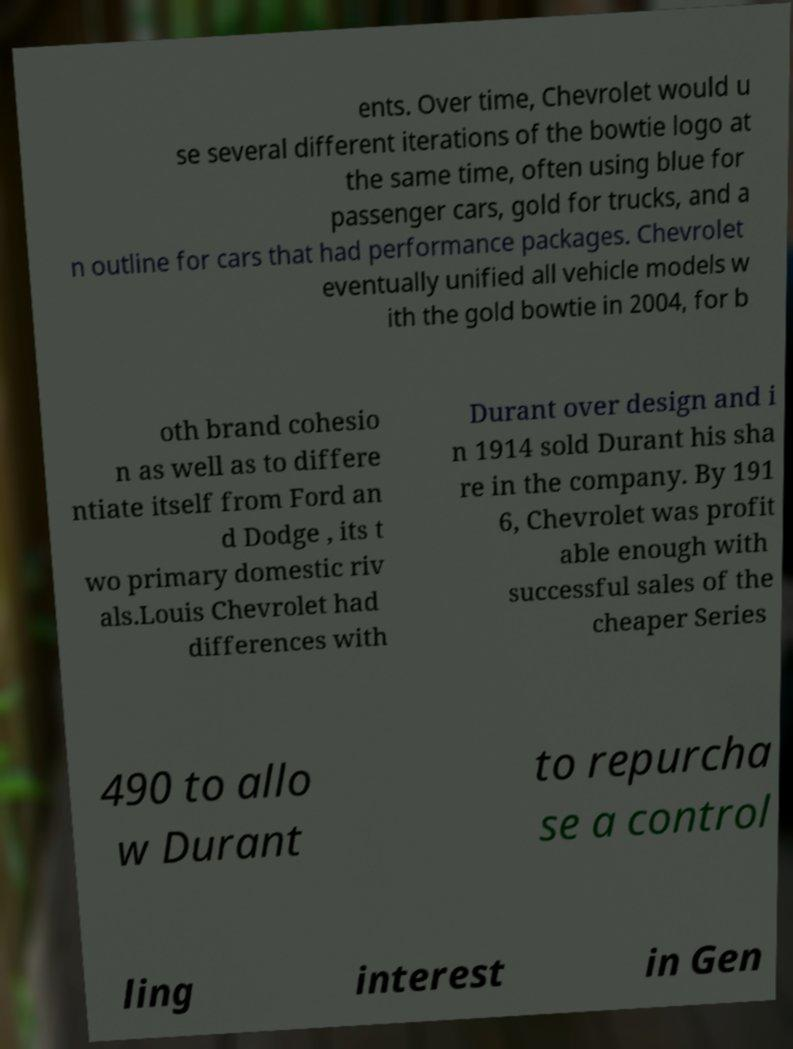Could you assist in decoding the text presented in this image and type it out clearly? ents. Over time, Chevrolet would u se several different iterations of the bowtie logo at the same time, often using blue for passenger cars, gold for trucks, and a n outline for cars that had performance packages. Chevrolet eventually unified all vehicle models w ith the gold bowtie in 2004, for b oth brand cohesio n as well as to differe ntiate itself from Ford an d Dodge , its t wo primary domestic riv als.Louis Chevrolet had differences with Durant over design and i n 1914 sold Durant his sha re in the company. By 191 6, Chevrolet was profit able enough with successful sales of the cheaper Series 490 to allo w Durant to repurcha se a control ling interest in Gen 